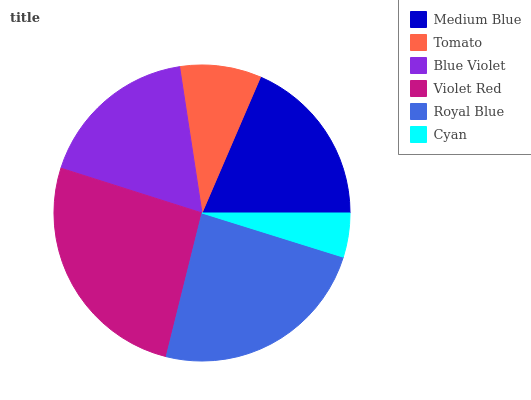Is Cyan the minimum?
Answer yes or no. Yes. Is Violet Red the maximum?
Answer yes or no. Yes. Is Tomato the minimum?
Answer yes or no. No. Is Tomato the maximum?
Answer yes or no. No. Is Medium Blue greater than Tomato?
Answer yes or no. Yes. Is Tomato less than Medium Blue?
Answer yes or no. Yes. Is Tomato greater than Medium Blue?
Answer yes or no. No. Is Medium Blue less than Tomato?
Answer yes or no. No. Is Medium Blue the high median?
Answer yes or no. Yes. Is Blue Violet the low median?
Answer yes or no. Yes. Is Royal Blue the high median?
Answer yes or no. No. Is Tomato the low median?
Answer yes or no. No. 